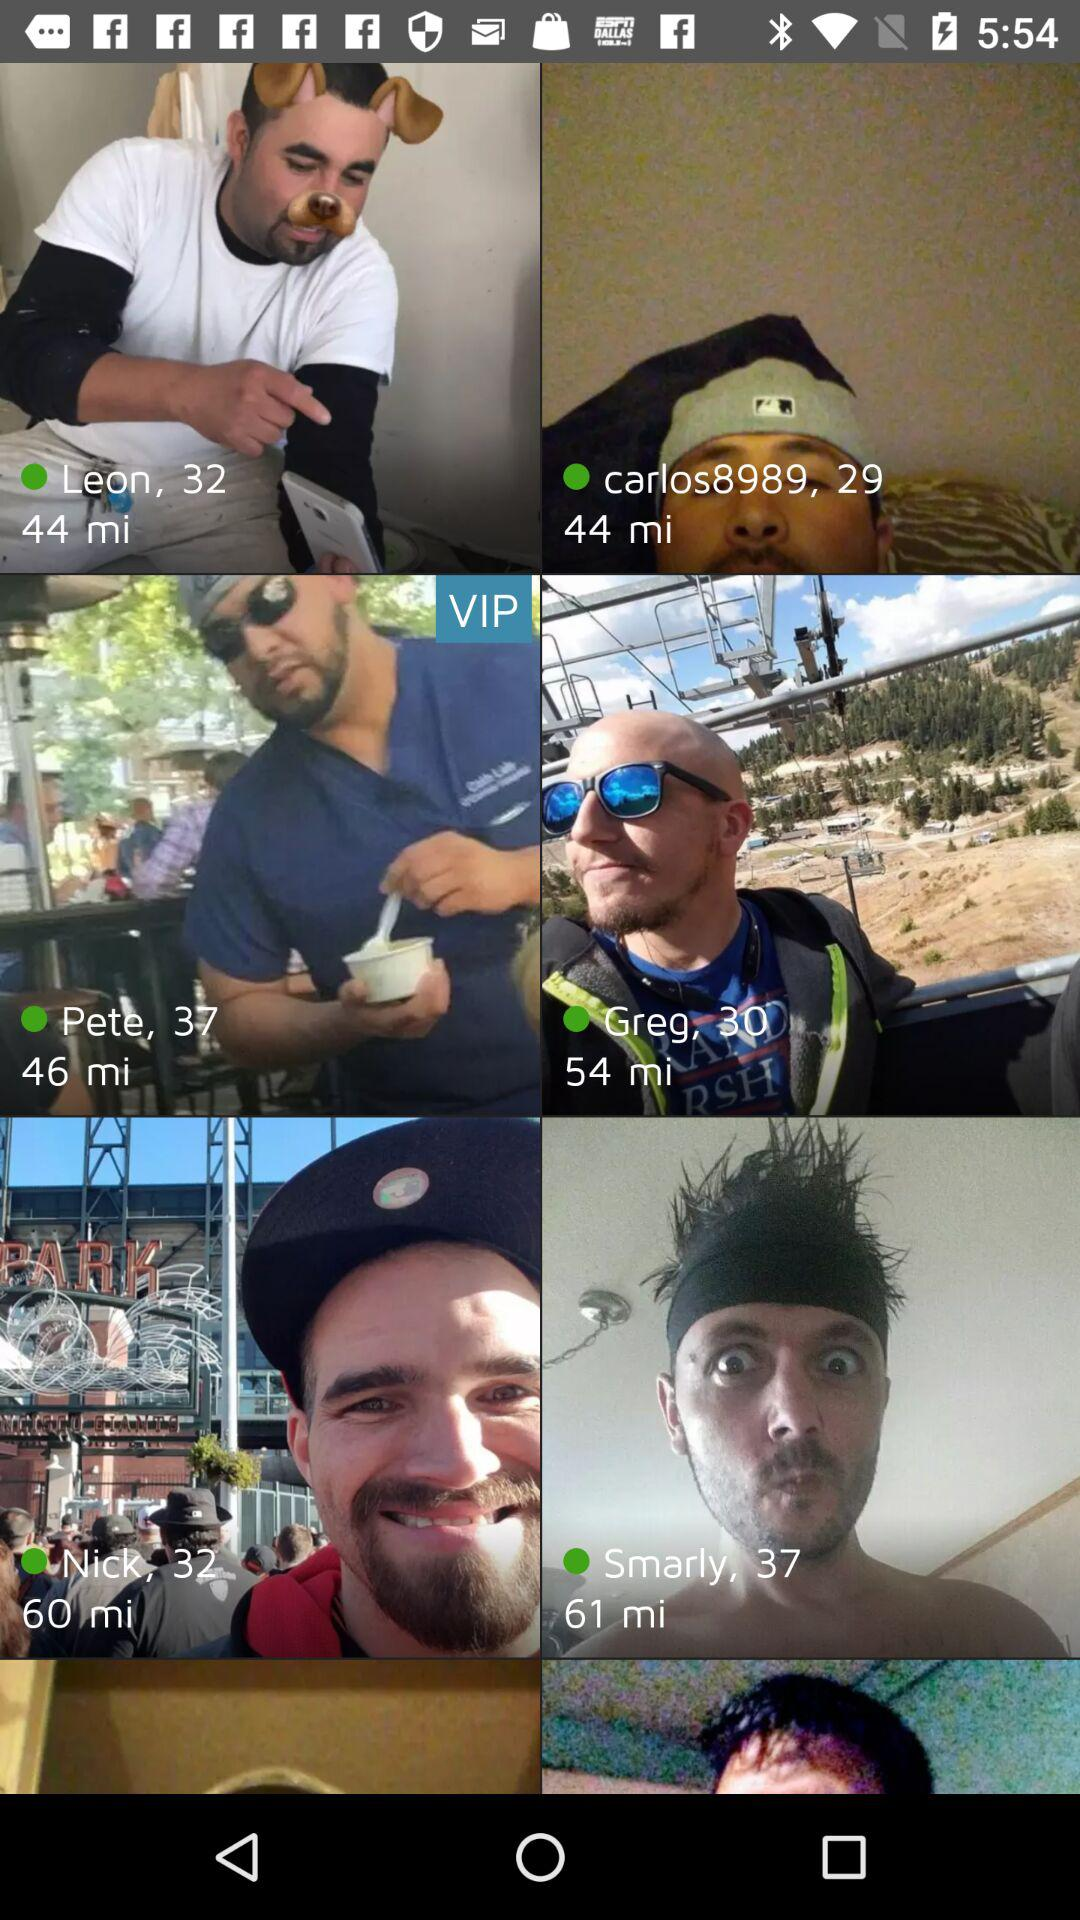Which of these people have 37 as their age? The people who have 37 as their age are "Pete" and "Smarly". 